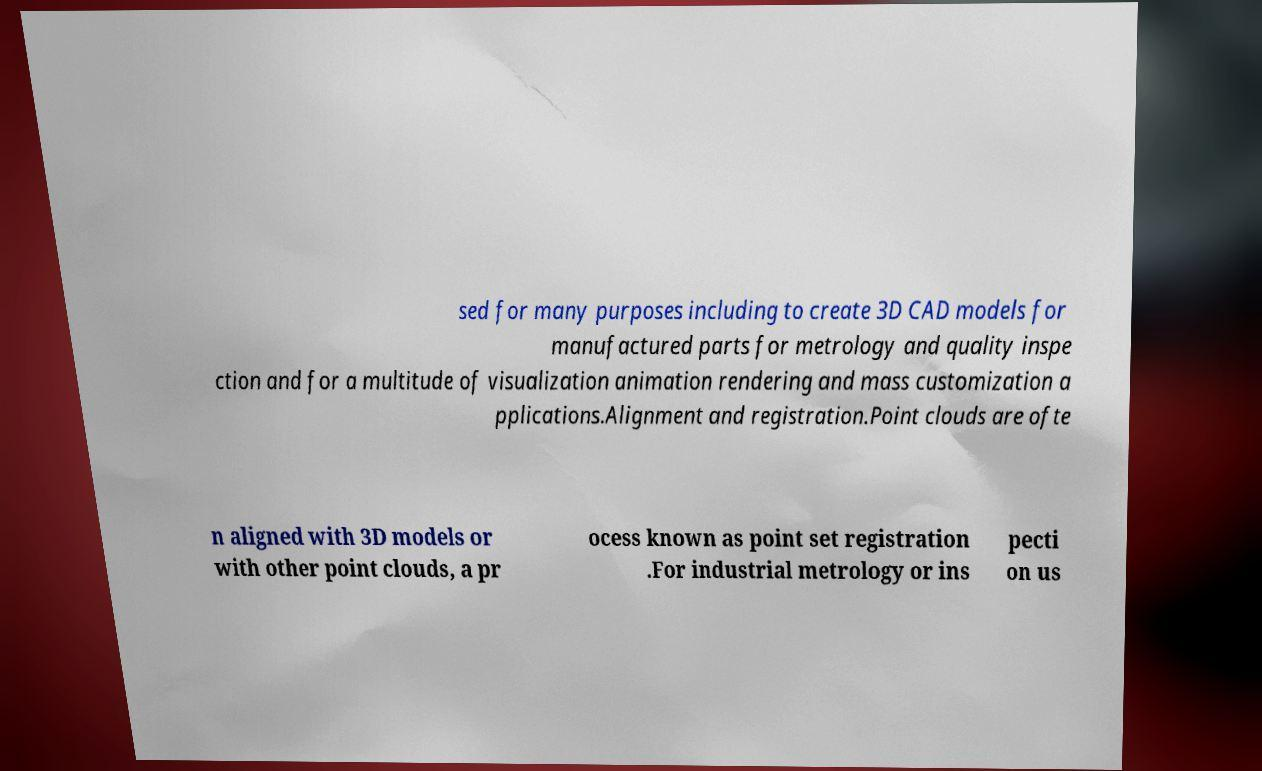Can you accurately transcribe the text from the provided image for me? sed for many purposes including to create 3D CAD models for manufactured parts for metrology and quality inspe ction and for a multitude of visualization animation rendering and mass customization a pplications.Alignment and registration.Point clouds are ofte n aligned with 3D models or with other point clouds, a pr ocess known as point set registration .For industrial metrology or ins pecti on us 